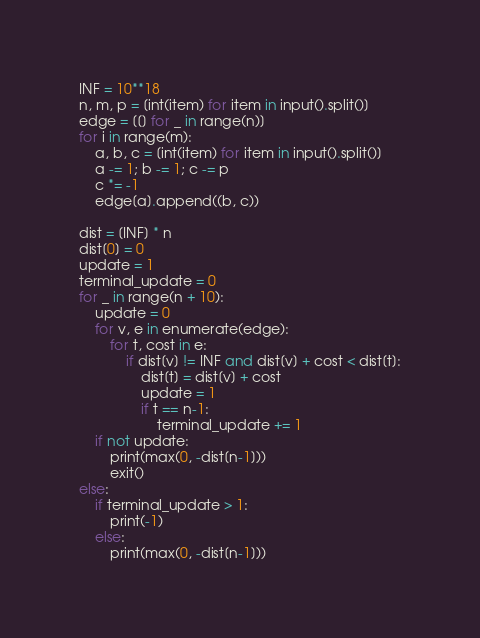<code> <loc_0><loc_0><loc_500><loc_500><_Python_>INF = 10**18
n, m, p = [int(item) for item in input().split()]
edge = [[] for _ in range(n)]
for i in range(m):
    a, b, c = [int(item) for item in input().split()]
    a -= 1; b -= 1; c -= p
    c *= -1
    edge[a].append((b, c))

dist = [INF] * n
dist[0] = 0
update = 1
terminal_update = 0
for _ in range(n + 10):
    update = 0
    for v, e in enumerate(edge):
        for t, cost in e:
            if dist[v] != INF and dist[v] + cost < dist[t]:
                dist[t] = dist[v] + cost
                update = 1
                if t == n-1:
                    terminal_update += 1
    if not update:
        print(max(0, -dist[n-1]))
        exit()
else:
    if terminal_update > 1:
        print(-1)
    else:
        print(max(0, -dist[n-1]))</code> 